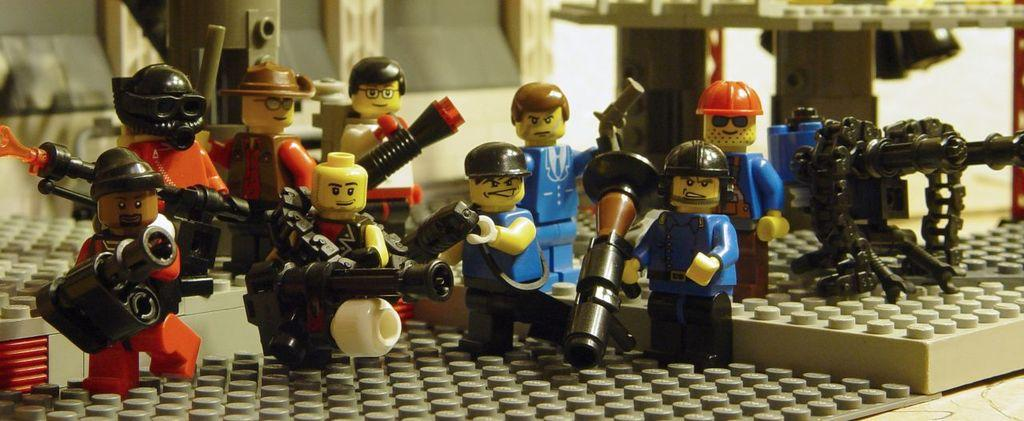Where was the image taken? The image was taken indoors. What is located at the bottom of the image? There is a table at the bottom of the image. What can be found on the table in the image? There are many toys on the table. What type of branch can be seen supporting the toys on the table? There is no branch present in the image; the toys are on a table without any visible support. 